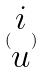Convert formula to latex. <formula><loc_0><loc_0><loc_500><loc_500>( \begin{matrix} i \\ u \end{matrix} )</formula> 